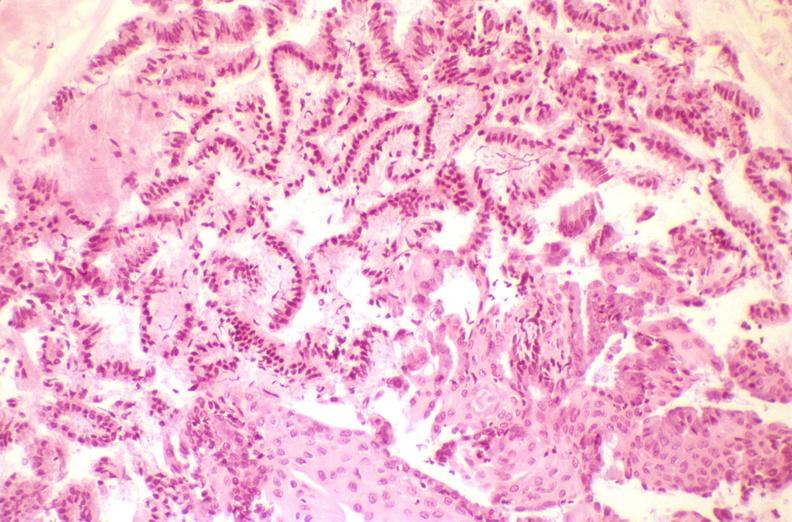where is this from?
Answer the question using a single word or phrase. Female reproductive system 